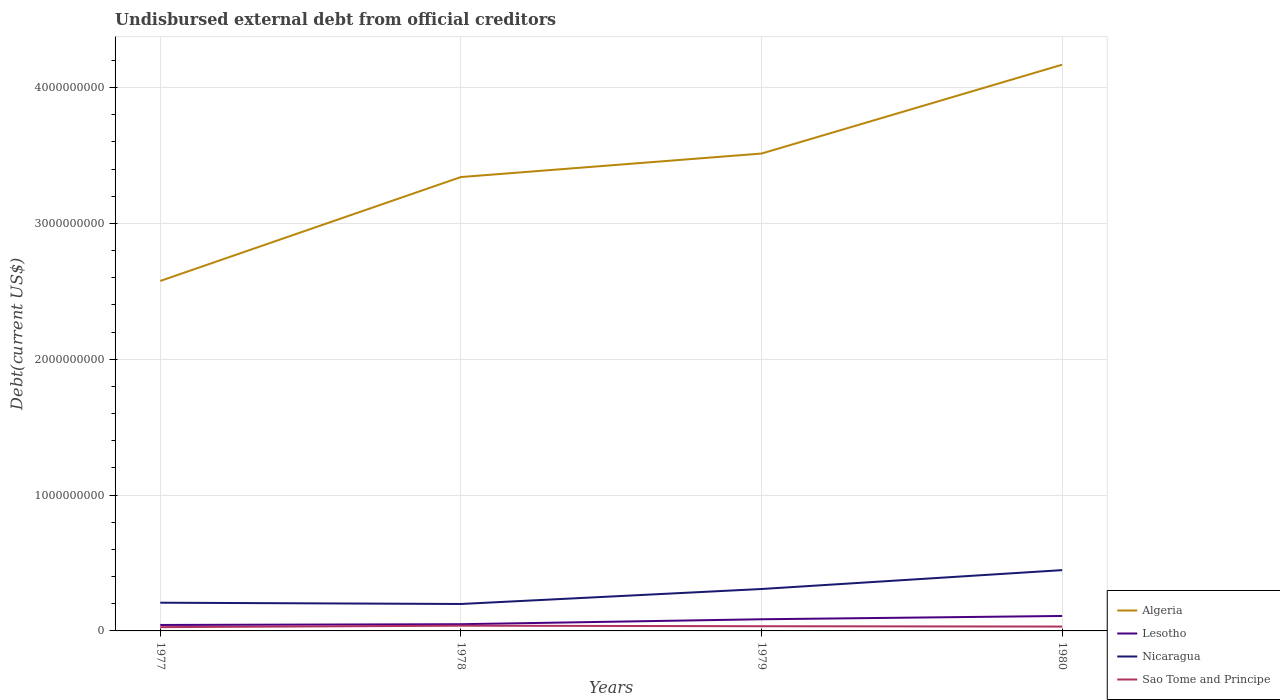Across all years, what is the maximum total debt in Nicaragua?
Keep it short and to the point. 1.98e+08. In which year was the total debt in Algeria maximum?
Provide a short and direct response. 1977. What is the total total debt in Sao Tome and Principe in the graph?
Provide a short and direct response. 2.44e+06. What is the difference between the highest and the second highest total debt in Nicaragua?
Provide a short and direct response. 2.49e+08. What is the difference between the highest and the lowest total debt in Nicaragua?
Offer a terse response. 2. How many lines are there?
Offer a terse response. 4. Are the values on the major ticks of Y-axis written in scientific E-notation?
Keep it short and to the point. No. Does the graph contain any zero values?
Provide a succinct answer. No. Where does the legend appear in the graph?
Your response must be concise. Bottom right. What is the title of the graph?
Ensure brevity in your answer.  Undisbursed external debt from official creditors. What is the label or title of the X-axis?
Give a very brief answer. Years. What is the label or title of the Y-axis?
Make the answer very short. Debt(current US$). What is the Debt(current US$) of Algeria in 1977?
Keep it short and to the point. 2.58e+09. What is the Debt(current US$) in Lesotho in 1977?
Ensure brevity in your answer.  4.39e+07. What is the Debt(current US$) of Nicaragua in 1977?
Your answer should be very brief. 2.08e+08. What is the Debt(current US$) in Sao Tome and Principe in 1977?
Your answer should be compact. 2.78e+07. What is the Debt(current US$) in Algeria in 1978?
Offer a terse response. 3.34e+09. What is the Debt(current US$) of Lesotho in 1978?
Your response must be concise. 4.95e+07. What is the Debt(current US$) in Nicaragua in 1978?
Give a very brief answer. 1.98e+08. What is the Debt(current US$) in Sao Tome and Principe in 1978?
Your response must be concise. 3.86e+07. What is the Debt(current US$) of Algeria in 1979?
Make the answer very short. 3.51e+09. What is the Debt(current US$) in Lesotho in 1979?
Provide a short and direct response. 8.58e+07. What is the Debt(current US$) of Nicaragua in 1979?
Your answer should be very brief. 3.09e+08. What is the Debt(current US$) of Sao Tome and Principe in 1979?
Offer a terse response. 3.46e+07. What is the Debt(current US$) of Algeria in 1980?
Keep it short and to the point. 4.17e+09. What is the Debt(current US$) in Lesotho in 1980?
Offer a terse response. 1.10e+08. What is the Debt(current US$) in Nicaragua in 1980?
Offer a very short reply. 4.48e+08. What is the Debt(current US$) of Sao Tome and Principe in 1980?
Your response must be concise. 3.21e+07. Across all years, what is the maximum Debt(current US$) in Algeria?
Offer a very short reply. 4.17e+09. Across all years, what is the maximum Debt(current US$) of Lesotho?
Provide a succinct answer. 1.10e+08. Across all years, what is the maximum Debt(current US$) in Nicaragua?
Offer a terse response. 4.48e+08. Across all years, what is the maximum Debt(current US$) of Sao Tome and Principe?
Make the answer very short. 3.86e+07. Across all years, what is the minimum Debt(current US$) in Algeria?
Ensure brevity in your answer.  2.58e+09. Across all years, what is the minimum Debt(current US$) in Lesotho?
Keep it short and to the point. 4.39e+07. Across all years, what is the minimum Debt(current US$) in Nicaragua?
Make the answer very short. 1.98e+08. Across all years, what is the minimum Debt(current US$) of Sao Tome and Principe?
Your answer should be compact. 2.78e+07. What is the total Debt(current US$) in Algeria in the graph?
Your answer should be very brief. 1.36e+1. What is the total Debt(current US$) of Lesotho in the graph?
Provide a short and direct response. 2.89e+08. What is the total Debt(current US$) in Nicaragua in the graph?
Ensure brevity in your answer.  1.16e+09. What is the total Debt(current US$) in Sao Tome and Principe in the graph?
Your answer should be very brief. 1.33e+08. What is the difference between the Debt(current US$) in Algeria in 1977 and that in 1978?
Your answer should be very brief. -7.65e+08. What is the difference between the Debt(current US$) in Lesotho in 1977 and that in 1978?
Provide a short and direct response. -5.61e+06. What is the difference between the Debt(current US$) in Nicaragua in 1977 and that in 1978?
Keep it short and to the point. 9.44e+06. What is the difference between the Debt(current US$) of Sao Tome and Principe in 1977 and that in 1978?
Give a very brief answer. -1.07e+07. What is the difference between the Debt(current US$) of Algeria in 1977 and that in 1979?
Offer a very short reply. -9.38e+08. What is the difference between the Debt(current US$) in Lesotho in 1977 and that in 1979?
Give a very brief answer. -4.19e+07. What is the difference between the Debt(current US$) of Nicaragua in 1977 and that in 1979?
Your response must be concise. -1.01e+08. What is the difference between the Debt(current US$) in Sao Tome and Principe in 1977 and that in 1979?
Give a very brief answer. -6.74e+06. What is the difference between the Debt(current US$) of Algeria in 1977 and that in 1980?
Make the answer very short. -1.59e+09. What is the difference between the Debt(current US$) in Lesotho in 1977 and that in 1980?
Give a very brief answer. -6.62e+07. What is the difference between the Debt(current US$) of Nicaragua in 1977 and that in 1980?
Make the answer very short. -2.40e+08. What is the difference between the Debt(current US$) in Sao Tome and Principe in 1977 and that in 1980?
Offer a very short reply. -4.30e+06. What is the difference between the Debt(current US$) of Algeria in 1978 and that in 1979?
Ensure brevity in your answer.  -1.73e+08. What is the difference between the Debt(current US$) of Lesotho in 1978 and that in 1979?
Make the answer very short. -3.63e+07. What is the difference between the Debt(current US$) in Nicaragua in 1978 and that in 1979?
Your answer should be very brief. -1.10e+08. What is the difference between the Debt(current US$) in Sao Tome and Principe in 1978 and that in 1979?
Make the answer very short. 3.99e+06. What is the difference between the Debt(current US$) of Algeria in 1978 and that in 1980?
Offer a very short reply. -8.27e+08. What is the difference between the Debt(current US$) of Lesotho in 1978 and that in 1980?
Offer a very short reply. -6.06e+07. What is the difference between the Debt(current US$) in Nicaragua in 1978 and that in 1980?
Give a very brief answer. -2.49e+08. What is the difference between the Debt(current US$) of Sao Tome and Principe in 1978 and that in 1980?
Your answer should be very brief. 6.43e+06. What is the difference between the Debt(current US$) of Algeria in 1979 and that in 1980?
Offer a very short reply. -6.54e+08. What is the difference between the Debt(current US$) of Lesotho in 1979 and that in 1980?
Provide a succinct answer. -2.43e+07. What is the difference between the Debt(current US$) of Nicaragua in 1979 and that in 1980?
Ensure brevity in your answer.  -1.39e+08. What is the difference between the Debt(current US$) of Sao Tome and Principe in 1979 and that in 1980?
Provide a short and direct response. 2.44e+06. What is the difference between the Debt(current US$) of Algeria in 1977 and the Debt(current US$) of Lesotho in 1978?
Ensure brevity in your answer.  2.53e+09. What is the difference between the Debt(current US$) in Algeria in 1977 and the Debt(current US$) in Nicaragua in 1978?
Your answer should be compact. 2.38e+09. What is the difference between the Debt(current US$) in Algeria in 1977 and the Debt(current US$) in Sao Tome and Principe in 1978?
Your answer should be compact. 2.54e+09. What is the difference between the Debt(current US$) of Lesotho in 1977 and the Debt(current US$) of Nicaragua in 1978?
Offer a terse response. -1.54e+08. What is the difference between the Debt(current US$) of Lesotho in 1977 and the Debt(current US$) of Sao Tome and Principe in 1978?
Make the answer very short. 5.30e+06. What is the difference between the Debt(current US$) of Nicaragua in 1977 and the Debt(current US$) of Sao Tome and Principe in 1978?
Give a very brief answer. 1.69e+08. What is the difference between the Debt(current US$) of Algeria in 1977 and the Debt(current US$) of Lesotho in 1979?
Make the answer very short. 2.49e+09. What is the difference between the Debt(current US$) of Algeria in 1977 and the Debt(current US$) of Nicaragua in 1979?
Make the answer very short. 2.27e+09. What is the difference between the Debt(current US$) of Algeria in 1977 and the Debt(current US$) of Sao Tome and Principe in 1979?
Ensure brevity in your answer.  2.54e+09. What is the difference between the Debt(current US$) in Lesotho in 1977 and the Debt(current US$) in Nicaragua in 1979?
Make the answer very short. -2.65e+08. What is the difference between the Debt(current US$) in Lesotho in 1977 and the Debt(current US$) in Sao Tome and Principe in 1979?
Offer a very short reply. 9.30e+06. What is the difference between the Debt(current US$) of Nicaragua in 1977 and the Debt(current US$) of Sao Tome and Principe in 1979?
Your response must be concise. 1.73e+08. What is the difference between the Debt(current US$) in Algeria in 1977 and the Debt(current US$) in Lesotho in 1980?
Ensure brevity in your answer.  2.47e+09. What is the difference between the Debt(current US$) of Algeria in 1977 and the Debt(current US$) of Nicaragua in 1980?
Provide a succinct answer. 2.13e+09. What is the difference between the Debt(current US$) in Algeria in 1977 and the Debt(current US$) in Sao Tome and Principe in 1980?
Provide a succinct answer. 2.54e+09. What is the difference between the Debt(current US$) in Lesotho in 1977 and the Debt(current US$) in Nicaragua in 1980?
Your answer should be compact. -4.04e+08. What is the difference between the Debt(current US$) in Lesotho in 1977 and the Debt(current US$) in Sao Tome and Principe in 1980?
Your answer should be compact. 1.17e+07. What is the difference between the Debt(current US$) in Nicaragua in 1977 and the Debt(current US$) in Sao Tome and Principe in 1980?
Keep it short and to the point. 1.76e+08. What is the difference between the Debt(current US$) in Algeria in 1978 and the Debt(current US$) in Lesotho in 1979?
Offer a terse response. 3.26e+09. What is the difference between the Debt(current US$) in Algeria in 1978 and the Debt(current US$) in Nicaragua in 1979?
Make the answer very short. 3.03e+09. What is the difference between the Debt(current US$) of Algeria in 1978 and the Debt(current US$) of Sao Tome and Principe in 1979?
Ensure brevity in your answer.  3.31e+09. What is the difference between the Debt(current US$) of Lesotho in 1978 and the Debt(current US$) of Nicaragua in 1979?
Provide a succinct answer. -2.59e+08. What is the difference between the Debt(current US$) in Lesotho in 1978 and the Debt(current US$) in Sao Tome and Principe in 1979?
Your response must be concise. 1.49e+07. What is the difference between the Debt(current US$) of Nicaragua in 1978 and the Debt(current US$) of Sao Tome and Principe in 1979?
Provide a succinct answer. 1.64e+08. What is the difference between the Debt(current US$) in Algeria in 1978 and the Debt(current US$) in Lesotho in 1980?
Make the answer very short. 3.23e+09. What is the difference between the Debt(current US$) of Algeria in 1978 and the Debt(current US$) of Nicaragua in 1980?
Ensure brevity in your answer.  2.89e+09. What is the difference between the Debt(current US$) of Algeria in 1978 and the Debt(current US$) of Sao Tome and Principe in 1980?
Your answer should be very brief. 3.31e+09. What is the difference between the Debt(current US$) of Lesotho in 1978 and the Debt(current US$) of Nicaragua in 1980?
Provide a succinct answer. -3.98e+08. What is the difference between the Debt(current US$) in Lesotho in 1978 and the Debt(current US$) in Sao Tome and Principe in 1980?
Provide a succinct answer. 1.73e+07. What is the difference between the Debt(current US$) in Nicaragua in 1978 and the Debt(current US$) in Sao Tome and Principe in 1980?
Ensure brevity in your answer.  1.66e+08. What is the difference between the Debt(current US$) of Algeria in 1979 and the Debt(current US$) of Lesotho in 1980?
Offer a very short reply. 3.40e+09. What is the difference between the Debt(current US$) in Algeria in 1979 and the Debt(current US$) in Nicaragua in 1980?
Make the answer very short. 3.07e+09. What is the difference between the Debt(current US$) of Algeria in 1979 and the Debt(current US$) of Sao Tome and Principe in 1980?
Offer a terse response. 3.48e+09. What is the difference between the Debt(current US$) of Lesotho in 1979 and the Debt(current US$) of Nicaragua in 1980?
Your response must be concise. -3.62e+08. What is the difference between the Debt(current US$) in Lesotho in 1979 and the Debt(current US$) in Sao Tome and Principe in 1980?
Your answer should be very brief. 5.37e+07. What is the difference between the Debt(current US$) of Nicaragua in 1979 and the Debt(current US$) of Sao Tome and Principe in 1980?
Provide a short and direct response. 2.76e+08. What is the average Debt(current US$) of Algeria per year?
Offer a very short reply. 3.40e+09. What is the average Debt(current US$) in Lesotho per year?
Provide a short and direct response. 7.23e+07. What is the average Debt(current US$) of Nicaragua per year?
Offer a very short reply. 2.91e+08. What is the average Debt(current US$) of Sao Tome and Principe per year?
Ensure brevity in your answer.  3.33e+07. In the year 1977, what is the difference between the Debt(current US$) of Algeria and Debt(current US$) of Lesotho?
Provide a succinct answer. 2.53e+09. In the year 1977, what is the difference between the Debt(current US$) in Algeria and Debt(current US$) in Nicaragua?
Keep it short and to the point. 2.37e+09. In the year 1977, what is the difference between the Debt(current US$) in Algeria and Debt(current US$) in Sao Tome and Principe?
Give a very brief answer. 2.55e+09. In the year 1977, what is the difference between the Debt(current US$) in Lesotho and Debt(current US$) in Nicaragua?
Make the answer very short. -1.64e+08. In the year 1977, what is the difference between the Debt(current US$) in Lesotho and Debt(current US$) in Sao Tome and Principe?
Offer a very short reply. 1.60e+07. In the year 1977, what is the difference between the Debt(current US$) in Nicaragua and Debt(current US$) in Sao Tome and Principe?
Provide a short and direct response. 1.80e+08. In the year 1978, what is the difference between the Debt(current US$) in Algeria and Debt(current US$) in Lesotho?
Ensure brevity in your answer.  3.29e+09. In the year 1978, what is the difference between the Debt(current US$) of Algeria and Debt(current US$) of Nicaragua?
Provide a succinct answer. 3.14e+09. In the year 1978, what is the difference between the Debt(current US$) of Algeria and Debt(current US$) of Sao Tome and Principe?
Your answer should be very brief. 3.30e+09. In the year 1978, what is the difference between the Debt(current US$) of Lesotho and Debt(current US$) of Nicaragua?
Your response must be concise. -1.49e+08. In the year 1978, what is the difference between the Debt(current US$) in Lesotho and Debt(current US$) in Sao Tome and Principe?
Give a very brief answer. 1.09e+07. In the year 1978, what is the difference between the Debt(current US$) of Nicaragua and Debt(current US$) of Sao Tome and Principe?
Provide a short and direct response. 1.60e+08. In the year 1979, what is the difference between the Debt(current US$) of Algeria and Debt(current US$) of Lesotho?
Offer a very short reply. 3.43e+09. In the year 1979, what is the difference between the Debt(current US$) of Algeria and Debt(current US$) of Nicaragua?
Make the answer very short. 3.21e+09. In the year 1979, what is the difference between the Debt(current US$) of Algeria and Debt(current US$) of Sao Tome and Principe?
Ensure brevity in your answer.  3.48e+09. In the year 1979, what is the difference between the Debt(current US$) of Lesotho and Debt(current US$) of Nicaragua?
Offer a very short reply. -2.23e+08. In the year 1979, what is the difference between the Debt(current US$) of Lesotho and Debt(current US$) of Sao Tome and Principe?
Offer a terse response. 5.12e+07. In the year 1979, what is the difference between the Debt(current US$) in Nicaragua and Debt(current US$) in Sao Tome and Principe?
Provide a short and direct response. 2.74e+08. In the year 1980, what is the difference between the Debt(current US$) in Algeria and Debt(current US$) in Lesotho?
Offer a terse response. 4.06e+09. In the year 1980, what is the difference between the Debt(current US$) in Algeria and Debt(current US$) in Nicaragua?
Your answer should be compact. 3.72e+09. In the year 1980, what is the difference between the Debt(current US$) of Algeria and Debt(current US$) of Sao Tome and Principe?
Your response must be concise. 4.14e+09. In the year 1980, what is the difference between the Debt(current US$) of Lesotho and Debt(current US$) of Nicaragua?
Your answer should be very brief. -3.38e+08. In the year 1980, what is the difference between the Debt(current US$) of Lesotho and Debt(current US$) of Sao Tome and Principe?
Make the answer very short. 7.79e+07. In the year 1980, what is the difference between the Debt(current US$) of Nicaragua and Debt(current US$) of Sao Tome and Principe?
Offer a terse response. 4.15e+08. What is the ratio of the Debt(current US$) in Algeria in 1977 to that in 1978?
Provide a short and direct response. 0.77. What is the ratio of the Debt(current US$) in Lesotho in 1977 to that in 1978?
Provide a short and direct response. 0.89. What is the ratio of the Debt(current US$) of Nicaragua in 1977 to that in 1978?
Your answer should be compact. 1.05. What is the ratio of the Debt(current US$) in Sao Tome and Principe in 1977 to that in 1978?
Keep it short and to the point. 0.72. What is the ratio of the Debt(current US$) in Algeria in 1977 to that in 1979?
Your answer should be compact. 0.73. What is the ratio of the Debt(current US$) of Lesotho in 1977 to that in 1979?
Provide a succinct answer. 0.51. What is the ratio of the Debt(current US$) of Nicaragua in 1977 to that in 1979?
Ensure brevity in your answer.  0.67. What is the ratio of the Debt(current US$) in Sao Tome and Principe in 1977 to that in 1979?
Make the answer very short. 0.81. What is the ratio of the Debt(current US$) in Algeria in 1977 to that in 1980?
Provide a short and direct response. 0.62. What is the ratio of the Debt(current US$) of Lesotho in 1977 to that in 1980?
Keep it short and to the point. 0.4. What is the ratio of the Debt(current US$) of Nicaragua in 1977 to that in 1980?
Your response must be concise. 0.46. What is the ratio of the Debt(current US$) of Sao Tome and Principe in 1977 to that in 1980?
Provide a succinct answer. 0.87. What is the ratio of the Debt(current US$) of Algeria in 1978 to that in 1979?
Your answer should be very brief. 0.95. What is the ratio of the Debt(current US$) in Lesotho in 1978 to that in 1979?
Offer a terse response. 0.58. What is the ratio of the Debt(current US$) of Nicaragua in 1978 to that in 1979?
Offer a terse response. 0.64. What is the ratio of the Debt(current US$) of Sao Tome and Principe in 1978 to that in 1979?
Ensure brevity in your answer.  1.12. What is the ratio of the Debt(current US$) of Algeria in 1978 to that in 1980?
Your answer should be very brief. 0.8. What is the ratio of the Debt(current US$) in Lesotho in 1978 to that in 1980?
Give a very brief answer. 0.45. What is the ratio of the Debt(current US$) of Nicaragua in 1978 to that in 1980?
Keep it short and to the point. 0.44. What is the ratio of the Debt(current US$) in Sao Tome and Principe in 1978 to that in 1980?
Ensure brevity in your answer.  1.2. What is the ratio of the Debt(current US$) of Algeria in 1979 to that in 1980?
Your answer should be compact. 0.84. What is the ratio of the Debt(current US$) of Lesotho in 1979 to that in 1980?
Your answer should be very brief. 0.78. What is the ratio of the Debt(current US$) of Nicaragua in 1979 to that in 1980?
Keep it short and to the point. 0.69. What is the ratio of the Debt(current US$) in Sao Tome and Principe in 1979 to that in 1980?
Offer a terse response. 1.08. What is the difference between the highest and the second highest Debt(current US$) of Algeria?
Offer a very short reply. 6.54e+08. What is the difference between the highest and the second highest Debt(current US$) of Lesotho?
Provide a short and direct response. 2.43e+07. What is the difference between the highest and the second highest Debt(current US$) of Nicaragua?
Offer a terse response. 1.39e+08. What is the difference between the highest and the second highest Debt(current US$) of Sao Tome and Principe?
Your response must be concise. 3.99e+06. What is the difference between the highest and the lowest Debt(current US$) of Algeria?
Ensure brevity in your answer.  1.59e+09. What is the difference between the highest and the lowest Debt(current US$) of Lesotho?
Your answer should be very brief. 6.62e+07. What is the difference between the highest and the lowest Debt(current US$) in Nicaragua?
Give a very brief answer. 2.49e+08. What is the difference between the highest and the lowest Debt(current US$) in Sao Tome and Principe?
Provide a short and direct response. 1.07e+07. 